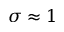<formula> <loc_0><loc_0><loc_500><loc_500>\sigma \approx 1</formula> 